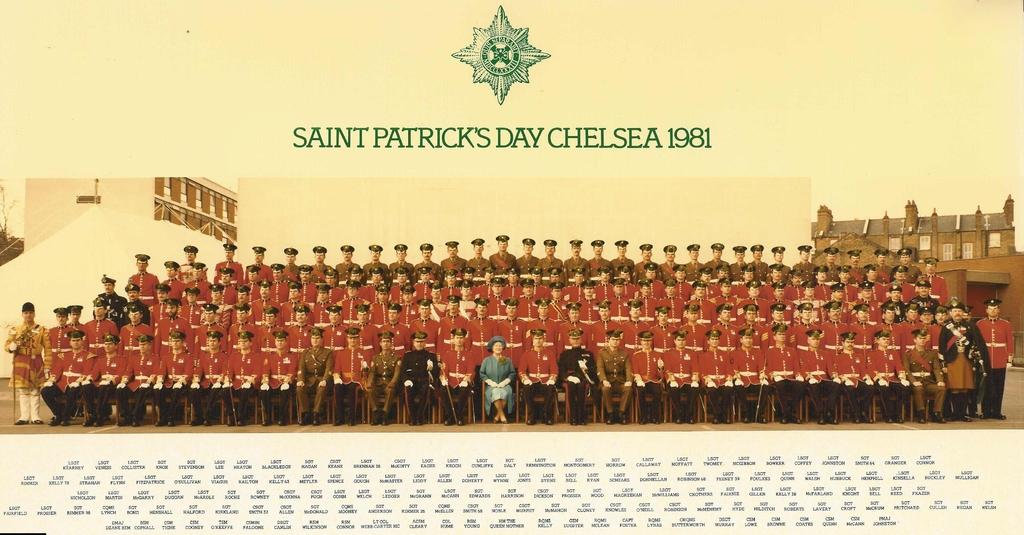<image>
Write a terse but informative summary of the picture. A picture of a bunch of people sitting in red uniforms titled SAINT PATRICK'S DAY CHELSEA 1981. 